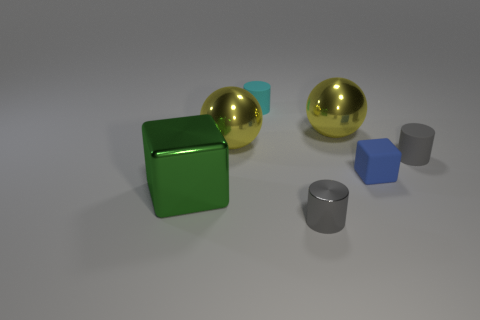There is a tiny thing that is right of the small blue thing; is it the same color as the tiny rubber block?
Make the answer very short. No. There is a small thing behind the gray thing that is behind the large green object; what is its shape?
Ensure brevity in your answer.  Cylinder. What number of objects are things behind the gray metal object or rubber objects that are behind the small gray rubber object?
Offer a terse response. 6. The cyan thing that is the same material as the small cube is what shape?
Provide a succinct answer. Cylinder. Is there anything else that is the same color as the tiny metal object?
Keep it short and to the point. Yes. What is the material of the big green object that is the same shape as the tiny blue matte object?
Offer a terse response. Metal. How many other things are there of the same size as the gray matte cylinder?
Offer a terse response. 3. What is the small blue object made of?
Ensure brevity in your answer.  Rubber. Are there more big metal things to the right of the small blue rubber object than metal cubes?
Your answer should be very brief. No. Are any cyan shiny spheres visible?
Ensure brevity in your answer.  No. 